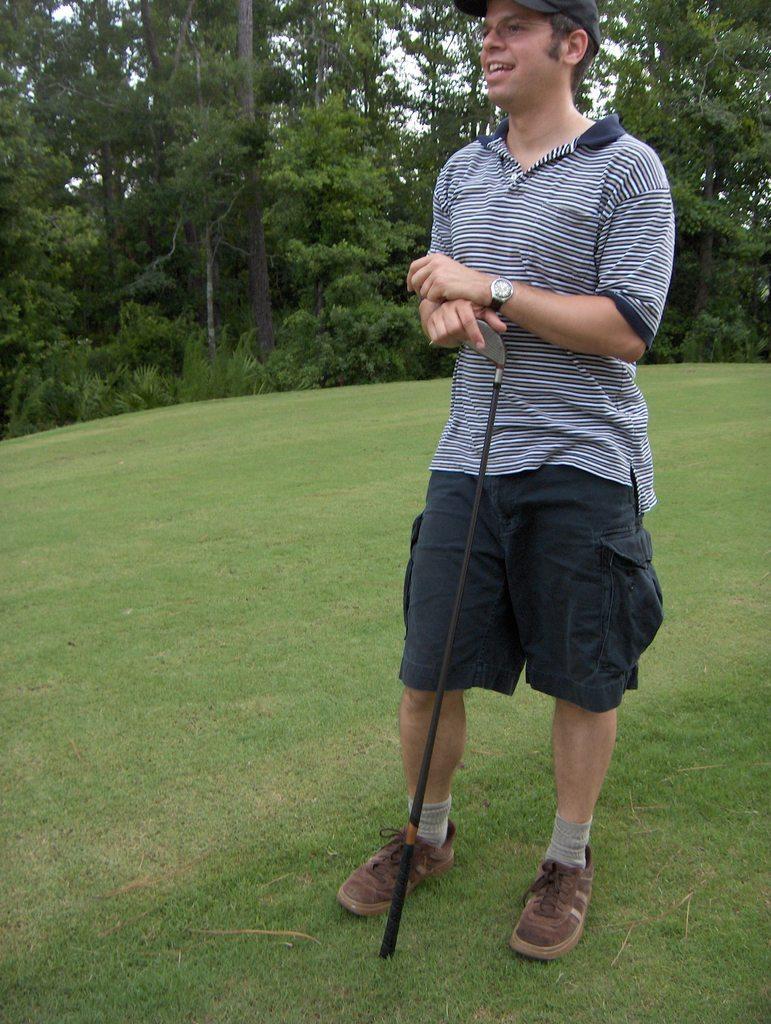Describe this image in one or two sentences. In this picture there is a man wearing a blue color t-shirt and shorts, standing in the golf ground and holding a golf stick in the hand. Behind there are many trees. 